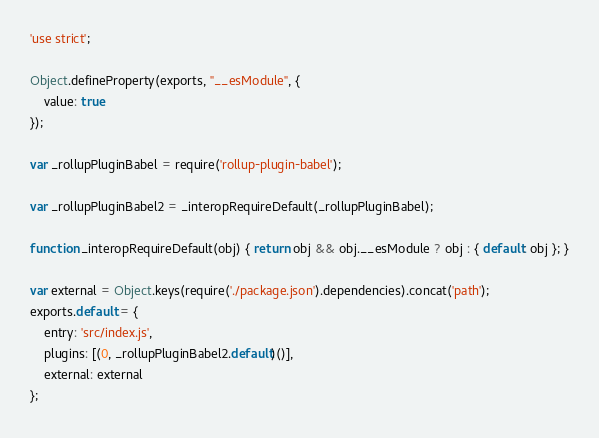<code> <loc_0><loc_0><loc_500><loc_500><_JavaScript_>'use strict';

Object.defineProperty(exports, "__esModule", {
	value: true
});

var _rollupPluginBabel = require('rollup-plugin-babel');

var _rollupPluginBabel2 = _interopRequireDefault(_rollupPluginBabel);

function _interopRequireDefault(obj) { return obj && obj.__esModule ? obj : { default: obj }; }

var external = Object.keys(require('./package.json').dependencies).concat('path');
exports.default = {
	entry: 'src/index.js',
	plugins: [(0, _rollupPluginBabel2.default)()],
	external: external
};</code> 